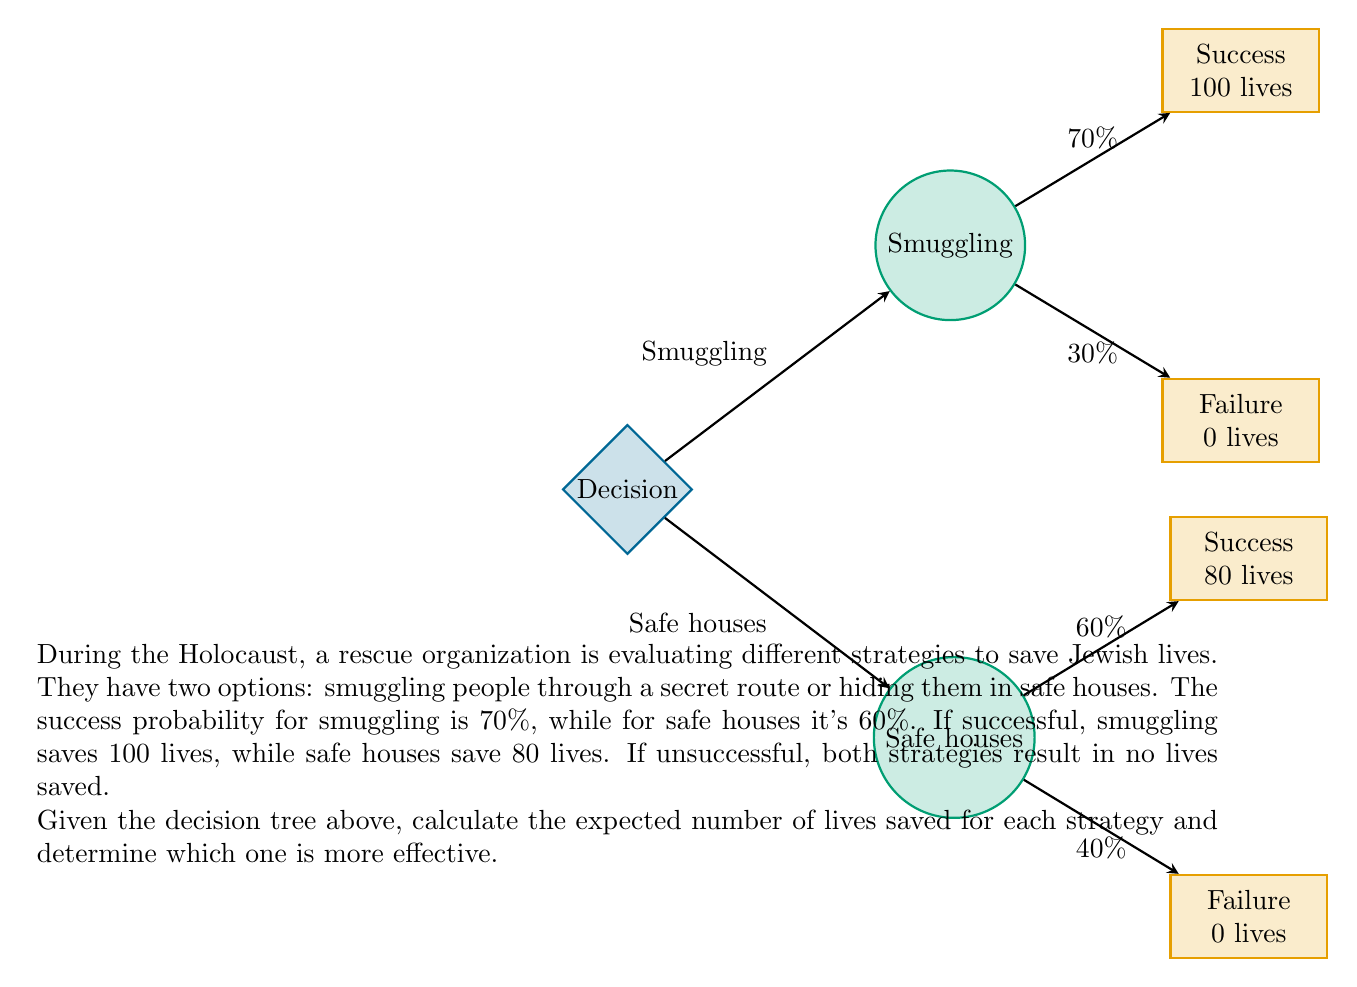What is the answer to this math problem? To solve this problem, we need to calculate the expected value for each strategy using the given probabilities and outcomes. Let's go through it step by step:

1. Smuggling Strategy:
   - Success probability: 70% (0.7)
   - Failure probability: 30% (0.3)
   - Lives saved if successful: 100
   - Lives saved if unsuccessful: 0

   Expected value calculation:
   $$E(\text{Smuggling}) = (0.7 \times 100) + (0.3 \times 0) = 70$$

2. Safe Houses Strategy:
   - Success probability: 60% (0.6)
   - Failure probability: 40% (0.4)
   - Lives saved if successful: 80
   - Lives saved if unsuccessful: 0

   Expected value calculation:
   $$E(\text{Safe Houses}) = (0.6 \times 80) + (0.4 \times 0) = 48$$

3. Comparison:
   The expected number of lives saved for the smuggling strategy (70) is higher than the expected number of lives saved for the safe houses strategy (48).

Therefore, based on the expected values, the smuggling strategy is more effective in saving lives.
Answer: Smuggling strategy (70 lives expected) 